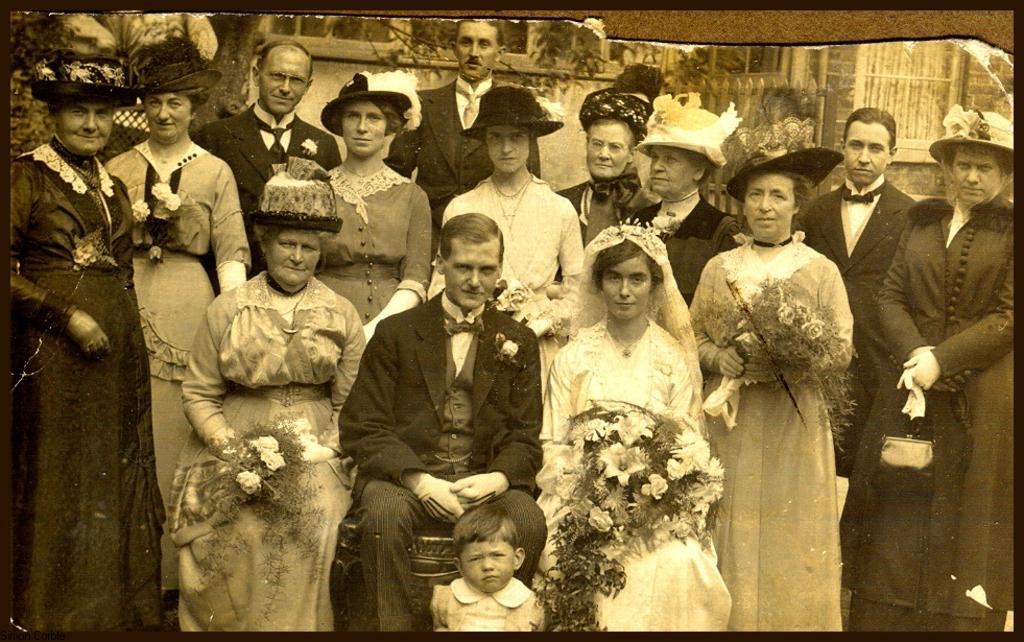Please provide a concise description of this image. This is an edited image with the borders. In the foreground we can see the three persons sitting and we can see a kid. In the background we can see the group of persons standing and we can see the handbag, bouquets and some other objects. In the background we can see the buildings and many other objects and we can see the leaves and the hats. 